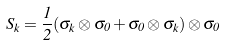Convert formula to latex. <formula><loc_0><loc_0><loc_500><loc_500>S _ { k } = \frac { 1 } { 2 } ( \sigma _ { k } \otimes \sigma _ { 0 } + \sigma _ { 0 } \otimes \sigma _ { k } ) \otimes \sigma _ { 0 }</formula> 